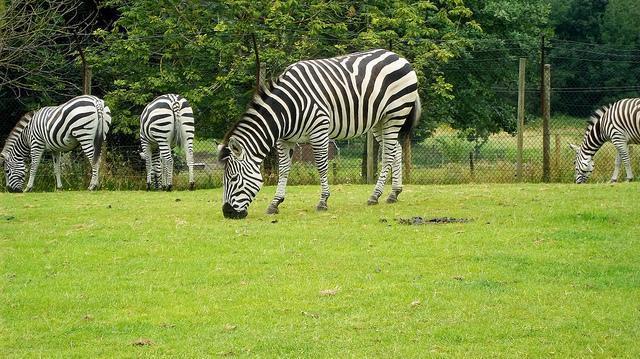How many zebras are in the picture?
Give a very brief answer. 4. How many zebras can be seen?
Give a very brief answer. 4. 